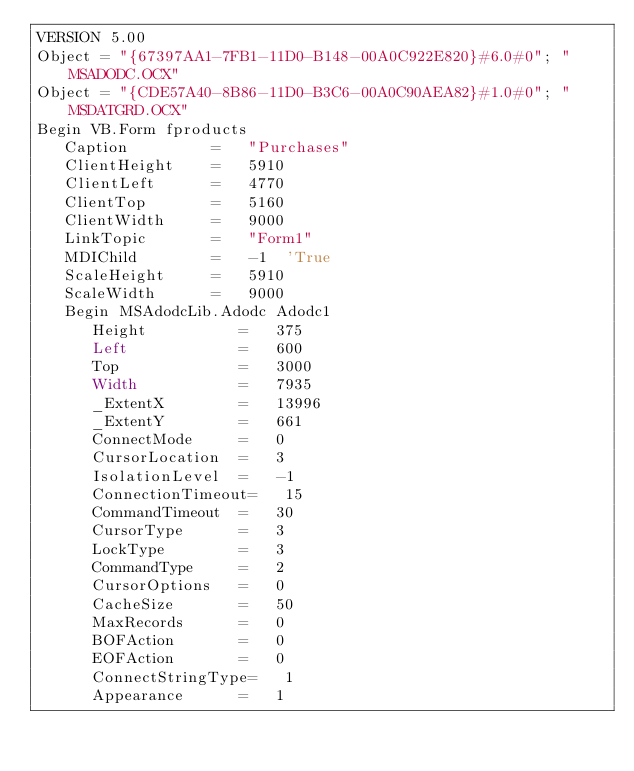<code> <loc_0><loc_0><loc_500><loc_500><_VisualBasic_>VERSION 5.00
Object = "{67397AA1-7FB1-11D0-B148-00A0C922E820}#6.0#0"; "MSADODC.OCX"
Object = "{CDE57A40-8B86-11D0-B3C6-00A0C90AEA82}#1.0#0"; "MSDATGRD.OCX"
Begin VB.Form fproducts 
   Caption         =   "Purchases"
   ClientHeight    =   5910
   ClientLeft      =   4770
   ClientTop       =   5160
   ClientWidth     =   9000
   LinkTopic       =   "Form1"
   MDIChild        =   -1  'True
   ScaleHeight     =   5910
   ScaleWidth      =   9000
   Begin MSAdodcLib.Adodc Adodc1 
      Height          =   375
      Left            =   600
      Top             =   3000
      Width           =   7935
      _ExtentX        =   13996
      _ExtentY        =   661
      ConnectMode     =   0
      CursorLocation  =   3
      IsolationLevel  =   -1
      ConnectionTimeout=   15
      CommandTimeout  =   30
      CursorType      =   3
      LockType        =   3
      CommandType     =   2
      CursorOptions   =   0
      CacheSize       =   50
      MaxRecords      =   0
      BOFAction       =   0
      EOFAction       =   0
      ConnectStringType=   1
      Appearance      =   1</code> 